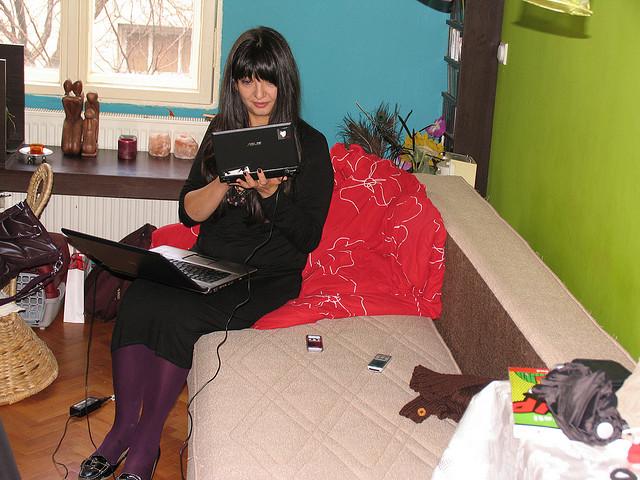Do you see any phones?
Answer briefly. Yes. What devices are the woman using?
Be succinct. Laptops. Is there a human in the image?
Concise answer only. Yes. Is the laptop power cord plugged in?
Write a very short answer. Yes. 